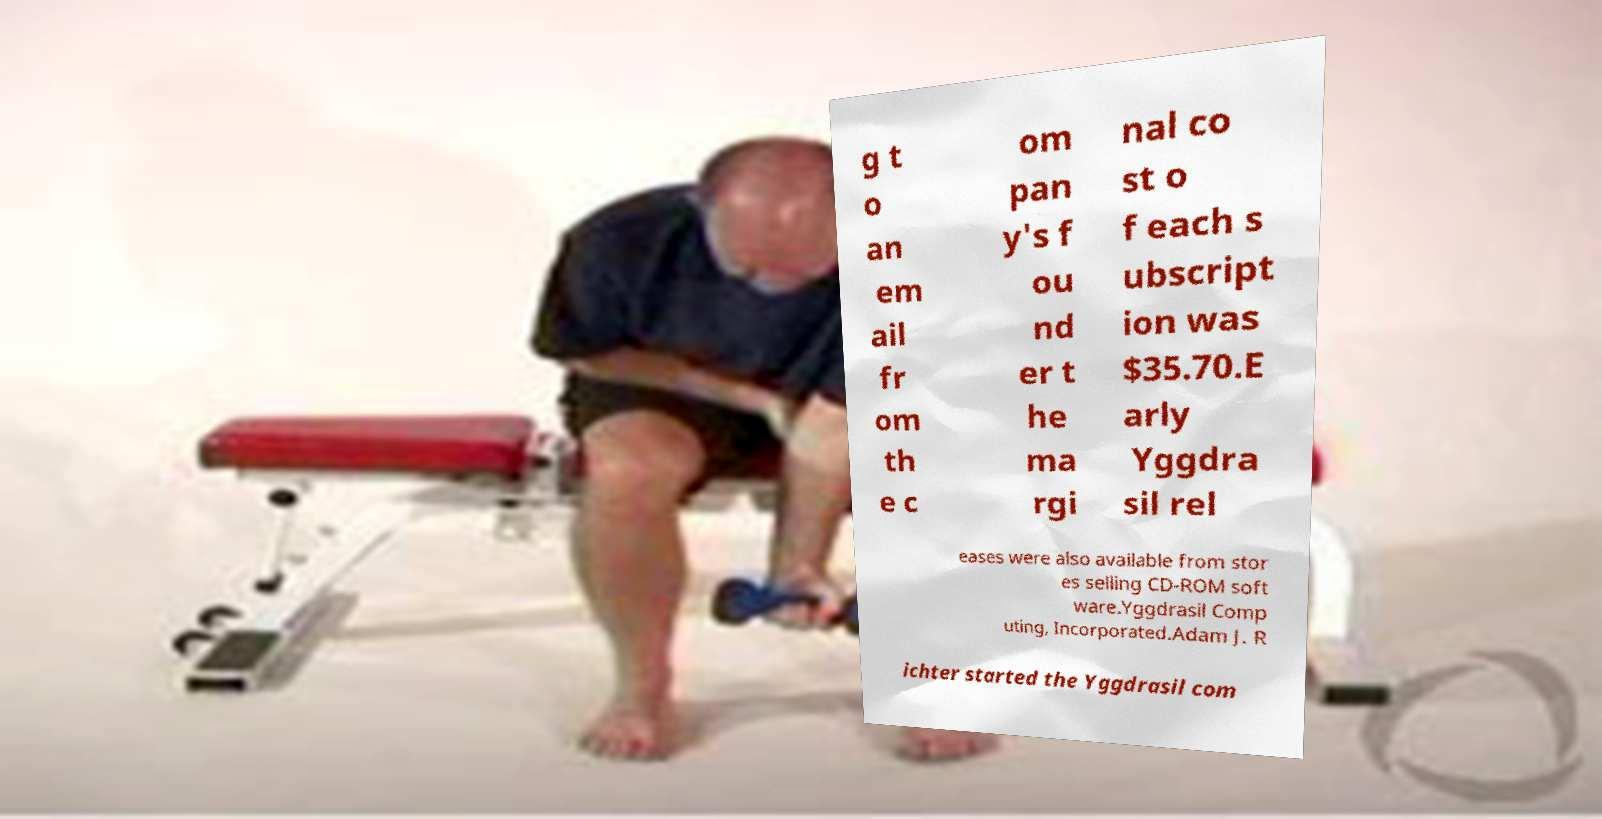Please identify and transcribe the text found in this image. g t o an em ail fr om th e c om pan y's f ou nd er t he ma rgi nal co st o f each s ubscript ion was $35.70.E arly Yggdra sil rel eases were also available from stor es selling CD-ROM soft ware.Yggdrasil Comp uting, Incorporated.Adam J. R ichter started the Yggdrasil com 